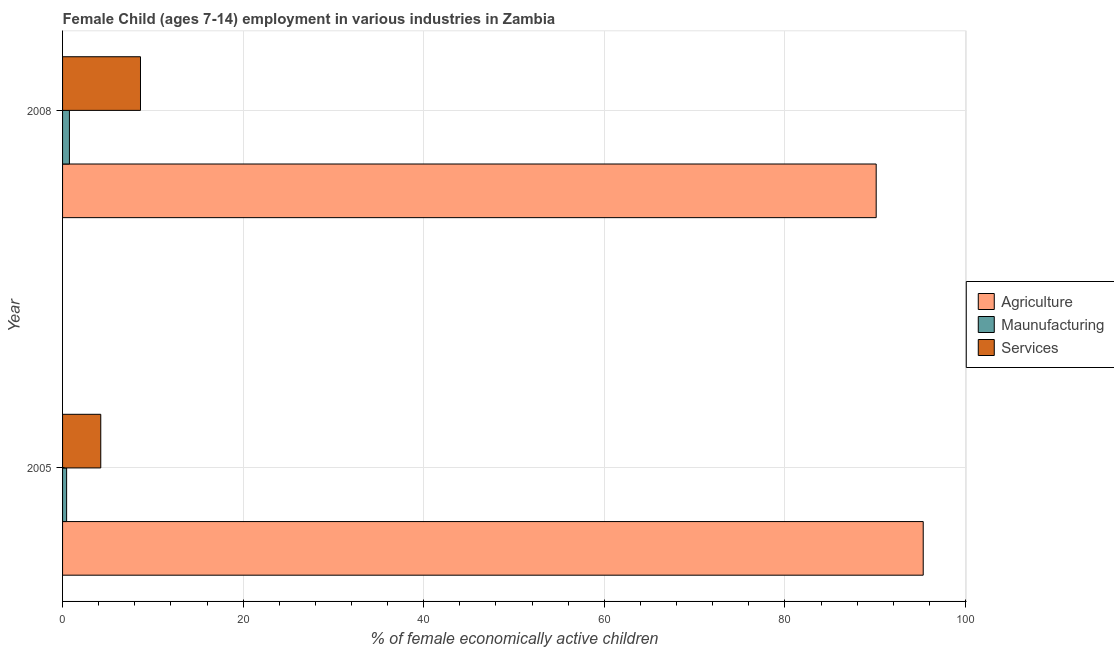How many different coloured bars are there?
Provide a short and direct response. 3. Are the number of bars per tick equal to the number of legend labels?
Provide a succinct answer. Yes. Are the number of bars on each tick of the Y-axis equal?
Provide a short and direct response. Yes. How many bars are there on the 1st tick from the top?
Provide a short and direct response. 3. How many bars are there on the 1st tick from the bottom?
Offer a terse response. 3. What is the percentage of economically active children in agriculture in 2005?
Offer a very short reply. 95.32. Across all years, what is the maximum percentage of economically active children in agriculture?
Ensure brevity in your answer.  95.32. Across all years, what is the minimum percentage of economically active children in services?
Give a very brief answer. 4.23. In which year was the percentage of economically active children in agriculture minimum?
Offer a very short reply. 2008. What is the total percentage of economically active children in manufacturing in the graph?
Your answer should be very brief. 1.21. What is the difference between the percentage of economically active children in services in 2008 and the percentage of economically active children in agriculture in 2005?
Ensure brevity in your answer.  -86.69. What is the average percentage of economically active children in agriculture per year?
Your response must be concise. 92.72. In the year 2008, what is the difference between the percentage of economically active children in manufacturing and percentage of economically active children in services?
Offer a very short reply. -7.87. In how many years, is the percentage of economically active children in manufacturing greater than 40 %?
Offer a terse response. 0. What is the ratio of the percentage of economically active children in agriculture in 2005 to that in 2008?
Provide a short and direct response. 1.06. Is the difference between the percentage of economically active children in services in 2005 and 2008 greater than the difference between the percentage of economically active children in manufacturing in 2005 and 2008?
Offer a terse response. No. In how many years, is the percentage of economically active children in agriculture greater than the average percentage of economically active children in agriculture taken over all years?
Offer a terse response. 1. What does the 2nd bar from the top in 2008 represents?
Your response must be concise. Maunufacturing. What does the 2nd bar from the bottom in 2005 represents?
Give a very brief answer. Maunufacturing. What is the difference between two consecutive major ticks on the X-axis?
Your answer should be very brief. 20. Are the values on the major ticks of X-axis written in scientific E-notation?
Offer a very short reply. No. Does the graph contain any zero values?
Your answer should be compact. No. Does the graph contain grids?
Your answer should be compact. Yes. Where does the legend appear in the graph?
Give a very brief answer. Center right. How many legend labels are there?
Offer a terse response. 3. How are the legend labels stacked?
Your answer should be compact. Vertical. What is the title of the graph?
Provide a short and direct response. Female Child (ages 7-14) employment in various industries in Zambia. Does "Profit Tax" appear as one of the legend labels in the graph?
Offer a terse response. No. What is the label or title of the X-axis?
Give a very brief answer. % of female economically active children. What is the % of female economically active children in Agriculture in 2005?
Make the answer very short. 95.32. What is the % of female economically active children in Maunufacturing in 2005?
Ensure brevity in your answer.  0.45. What is the % of female economically active children of Services in 2005?
Give a very brief answer. 4.23. What is the % of female economically active children of Agriculture in 2008?
Ensure brevity in your answer.  90.11. What is the % of female economically active children in Maunufacturing in 2008?
Make the answer very short. 0.76. What is the % of female economically active children of Services in 2008?
Keep it short and to the point. 8.63. Across all years, what is the maximum % of female economically active children of Agriculture?
Ensure brevity in your answer.  95.32. Across all years, what is the maximum % of female economically active children in Maunufacturing?
Offer a terse response. 0.76. Across all years, what is the maximum % of female economically active children of Services?
Provide a succinct answer. 8.63. Across all years, what is the minimum % of female economically active children of Agriculture?
Provide a succinct answer. 90.11. Across all years, what is the minimum % of female economically active children of Maunufacturing?
Offer a terse response. 0.45. Across all years, what is the minimum % of female economically active children in Services?
Keep it short and to the point. 4.23. What is the total % of female economically active children of Agriculture in the graph?
Keep it short and to the point. 185.43. What is the total % of female economically active children of Maunufacturing in the graph?
Offer a terse response. 1.21. What is the total % of female economically active children in Services in the graph?
Ensure brevity in your answer.  12.86. What is the difference between the % of female economically active children of Agriculture in 2005 and that in 2008?
Provide a succinct answer. 5.21. What is the difference between the % of female economically active children of Maunufacturing in 2005 and that in 2008?
Your response must be concise. -0.31. What is the difference between the % of female economically active children of Services in 2005 and that in 2008?
Provide a short and direct response. -4.4. What is the difference between the % of female economically active children in Agriculture in 2005 and the % of female economically active children in Maunufacturing in 2008?
Give a very brief answer. 94.56. What is the difference between the % of female economically active children of Agriculture in 2005 and the % of female economically active children of Services in 2008?
Ensure brevity in your answer.  86.69. What is the difference between the % of female economically active children of Maunufacturing in 2005 and the % of female economically active children of Services in 2008?
Your answer should be compact. -8.18. What is the average % of female economically active children of Agriculture per year?
Keep it short and to the point. 92.72. What is the average % of female economically active children in Maunufacturing per year?
Provide a short and direct response. 0.6. What is the average % of female economically active children in Services per year?
Provide a succinct answer. 6.43. In the year 2005, what is the difference between the % of female economically active children in Agriculture and % of female economically active children in Maunufacturing?
Your answer should be very brief. 94.87. In the year 2005, what is the difference between the % of female economically active children of Agriculture and % of female economically active children of Services?
Make the answer very short. 91.09. In the year 2005, what is the difference between the % of female economically active children in Maunufacturing and % of female economically active children in Services?
Your answer should be very brief. -3.78. In the year 2008, what is the difference between the % of female economically active children in Agriculture and % of female economically active children in Maunufacturing?
Give a very brief answer. 89.35. In the year 2008, what is the difference between the % of female economically active children of Agriculture and % of female economically active children of Services?
Give a very brief answer. 81.48. In the year 2008, what is the difference between the % of female economically active children of Maunufacturing and % of female economically active children of Services?
Offer a very short reply. -7.87. What is the ratio of the % of female economically active children in Agriculture in 2005 to that in 2008?
Your response must be concise. 1.06. What is the ratio of the % of female economically active children in Maunufacturing in 2005 to that in 2008?
Provide a succinct answer. 0.59. What is the ratio of the % of female economically active children in Services in 2005 to that in 2008?
Provide a succinct answer. 0.49. What is the difference between the highest and the second highest % of female economically active children in Agriculture?
Ensure brevity in your answer.  5.21. What is the difference between the highest and the second highest % of female economically active children in Maunufacturing?
Your answer should be very brief. 0.31. What is the difference between the highest and the lowest % of female economically active children in Agriculture?
Your response must be concise. 5.21. What is the difference between the highest and the lowest % of female economically active children in Maunufacturing?
Keep it short and to the point. 0.31. What is the difference between the highest and the lowest % of female economically active children in Services?
Your answer should be compact. 4.4. 